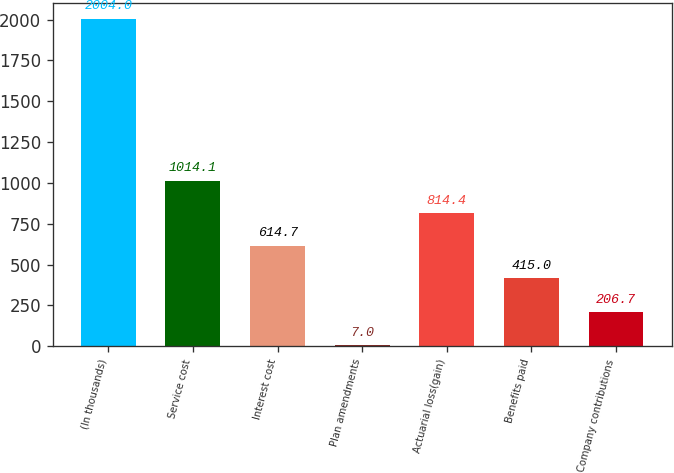Convert chart. <chart><loc_0><loc_0><loc_500><loc_500><bar_chart><fcel>(In thousands)<fcel>Service cost<fcel>Interest cost<fcel>Plan amendments<fcel>Actuarial loss(gain)<fcel>Benefits paid<fcel>Company contributions<nl><fcel>2004<fcel>1014.1<fcel>614.7<fcel>7<fcel>814.4<fcel>415<fcel>206.7<nl></chart> 